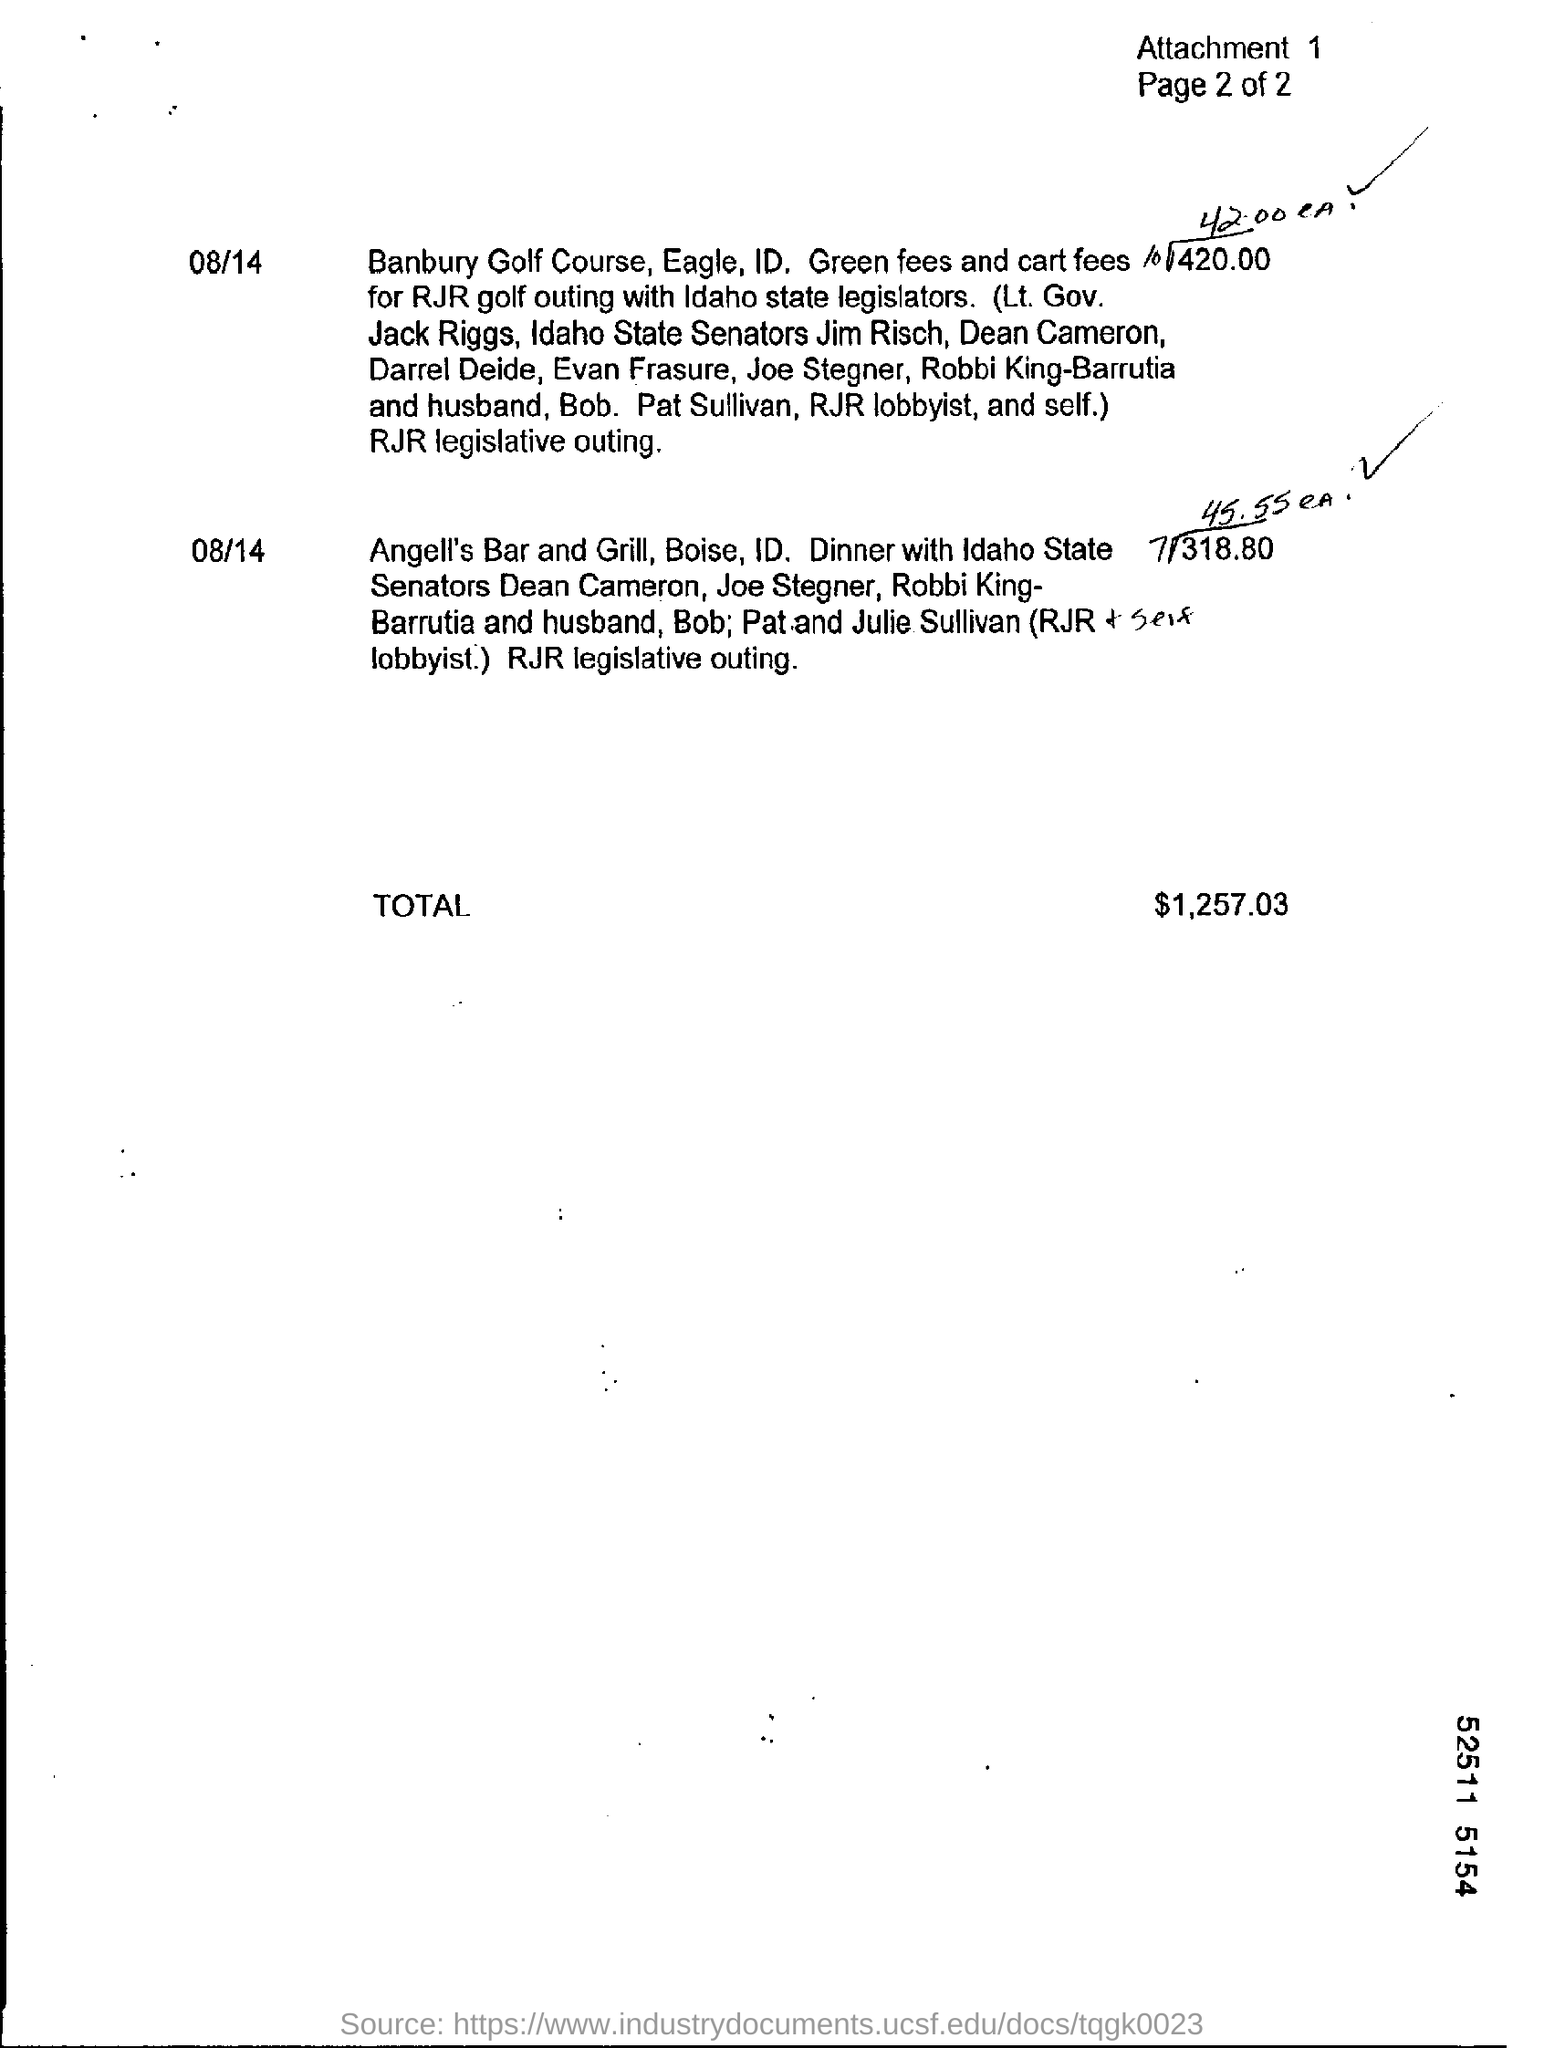What is the number of attachment?
Give a very brief answer. 1. What is the total amount?
Your answer should be very brief. $1,257.03. 